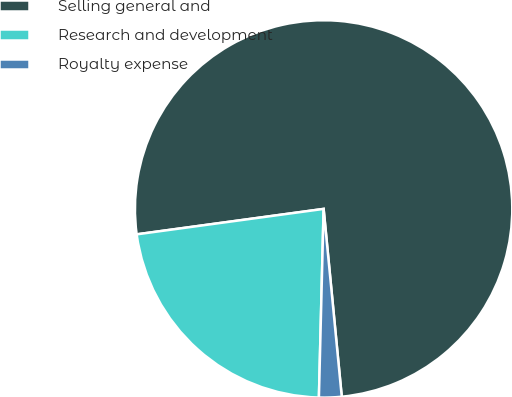<chart> <loc_0><loc_0><loc_500><loc_500><pie_chart><fcel>Selling general and<fcel>Research and development<fcel>Royalty expense<nl><fcel>75.62%<fcel>22.45%<fcel>1.93%<nl></chart> 